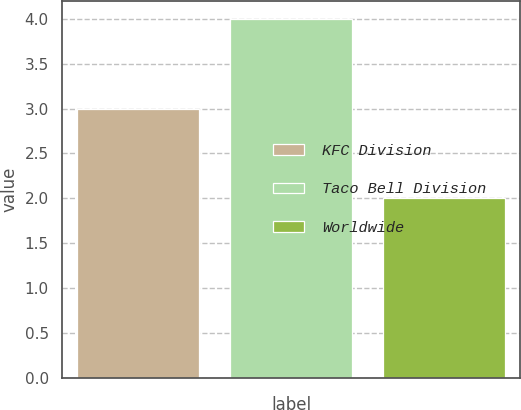Convert chart. <chart><loc_0><loc_0><loc_500><loc_500><bar_chart><fcel>KFC Division<fcel>Taco Bell Division<fcel>Worldwide<nl><fcel>3<fcel>4<fcel>2<nl></chart> 